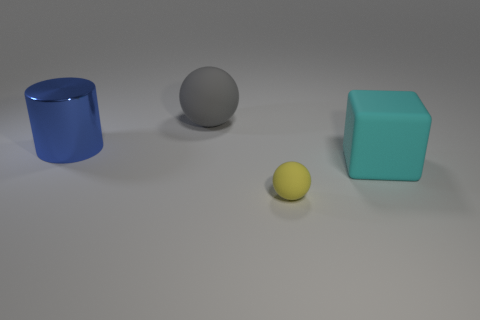Is there any other thing that has the same size as the yellow matte object?
Give a very brief answer. No. There is a thing that is left of the large rubber ball; what material is it?
Your response must be concise. Metal. How many objects are either things that are in front of the blue metal cylinder or blue objects?
Your answer should be compact. 3. What number of other things are there of the same shape as the gray rubber object?
Offer a terse response. 1. There is a matte object in front of the big cyan rubber thing; is it the same shape as the large gray thing?
Ensure brevity in your answer.  Yes. Are there any spheres on the right side of the yellow object?
Offer a very short reply. No. How many large things are either metallic things or balls?
Provide a short and direct response. 2. Is the material of the yellow object the same as the cube?
Give a very brief answer. Yes. There is another ball that is the same material as the big ball; what is its size?
Keep it short and to the point. Small. What is the shape of the object that is behind the blue metallic cylinder to the left of the rubber thing that is behind the large blue cylinder?
Provide a succinct answer. Sphere. 